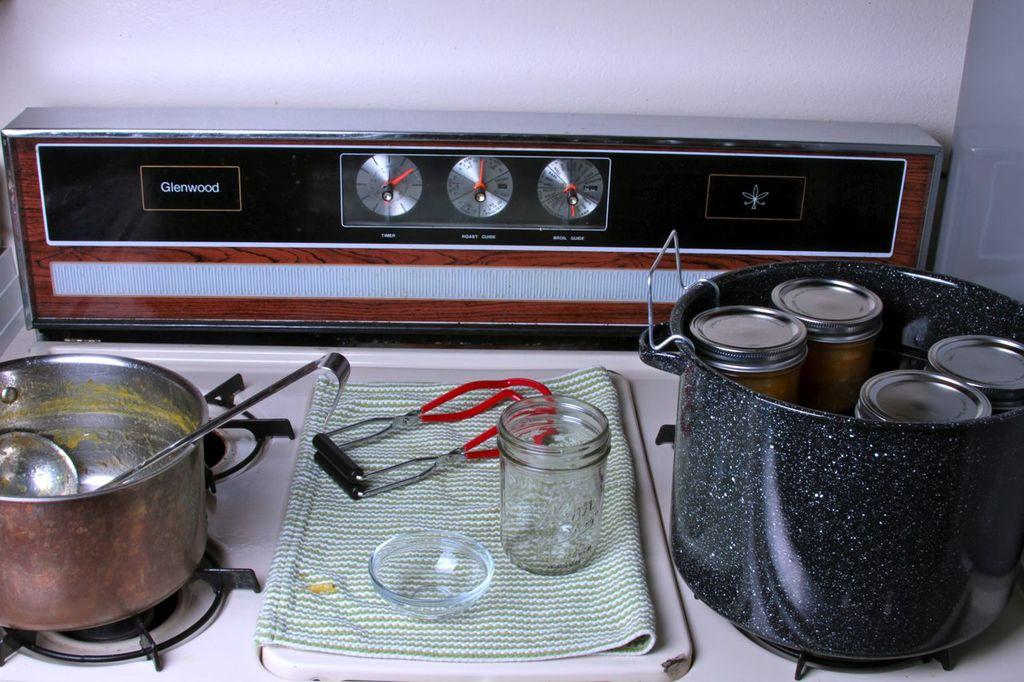<image>
Create a compact narrative representing the image presented. A Glenwood stove has some canning jars, utensils and pots for canning purposes. 